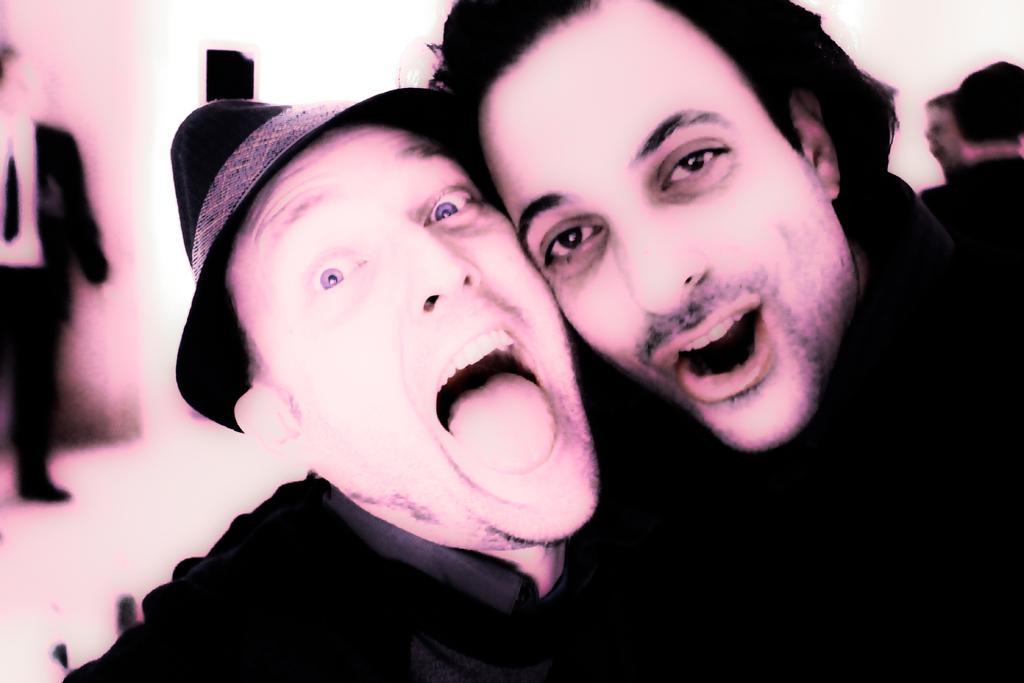Could you give a brief overview of what you see in this image? In this picture we can see two men in the front, a man on the left side is wearing a cap, there is a person standing in the background, we can see a blurry background. 